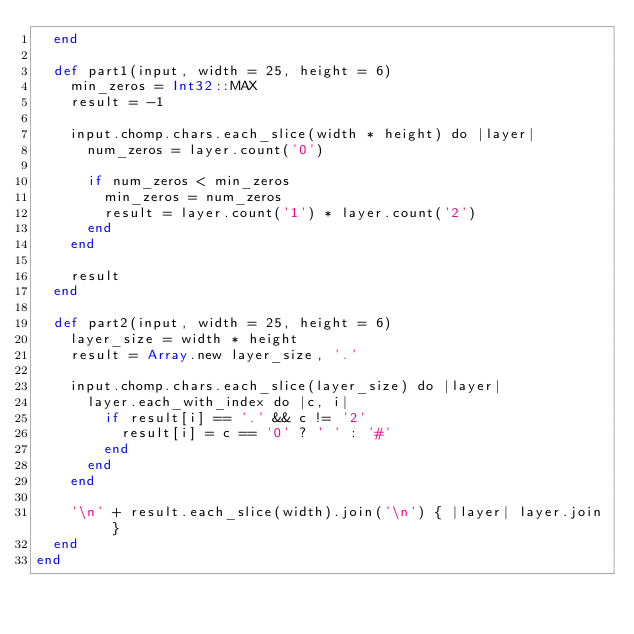<code> <loc_0><loc_0><loc_500><loc_500><_Crystal_>  end

  def part1(input, width = 25, height = 6)
    min_zeros = Int32::MAX
    result = -1

    input.chomp.chars.each_slice(width * height) do |layer|
      num_zeros = layer.count('0')

      if num_zeros < min_zeros
        min_zeros = num_zeros
        result = layer.count('1') * layer.count('2')
      end
    end

    result
  end

  def part2(input, width = 25, height = 6)
    layer_size = width * height
    result = Array.new layer_size, '.'

    input.chomp.chars.each_slice(layer_size) do |layer|
      layer.each_with_index do |c, i|
        if result[i] == '.' && c != '2'
          result[i] = c == '0' ? ' ' : '#'
        end
      end
    end

    '\n' + result.each_slice(width).join('\n') { |layer| layer.join }
  end
end
</code> 